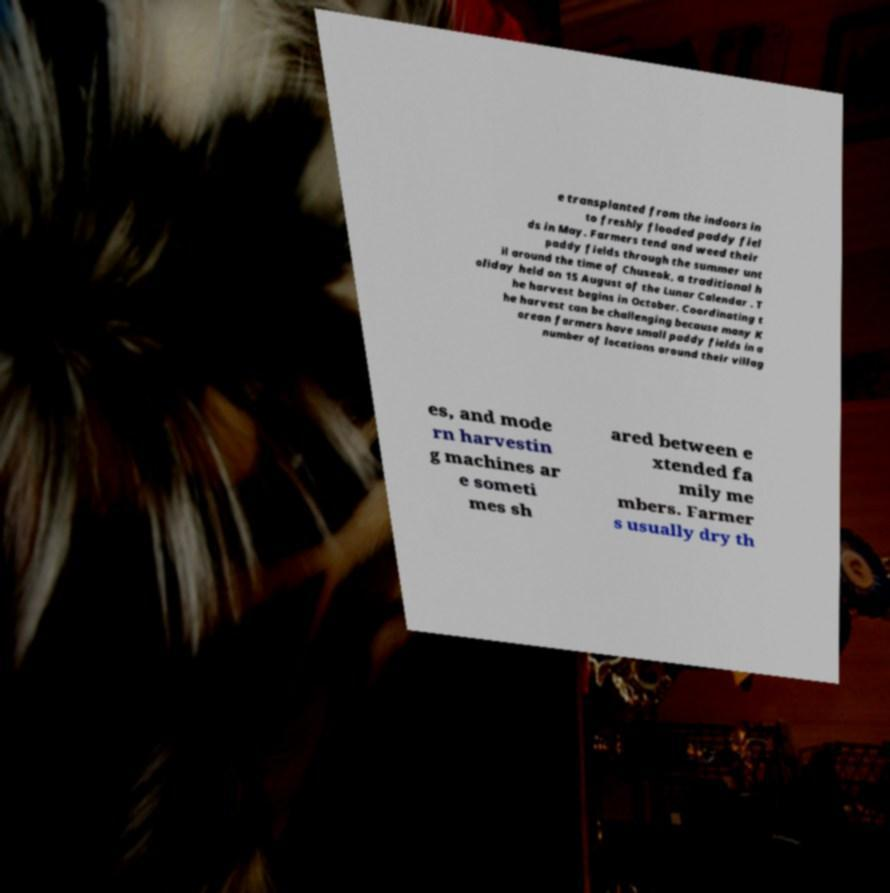There's text embedded in this image that I need extracted. Can you transcribe it verbatim? e transplanted from the indoors in to freshly flooded paddy fiel ds in May. Farmers tend and weed their paddy fields through the summer unt il around the time of Chuseok, a traditional h oliday held on 15 August of the Lunar Calendar . T he harvest begins in October. Coordinating t he harvest can be challenging because many K orean farmers have small paddy fields in a number of locations around their villag es, and mode rn harvestin g machines ar e someti mes sh ared between e xtended fa mily me mbers. Farmer s usually dry th 